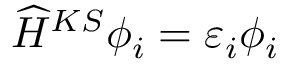<formula> <loc_0><loc_0><loc_500><loc_500>\widehat { H } ^ { K S } \phi _ { i } = \varepsilon _ { i } \phi _ { i }</formula> 